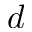Convert formula to latex. <formula><loc_0><loc_0><loc_500><loc_500>d</formula> 